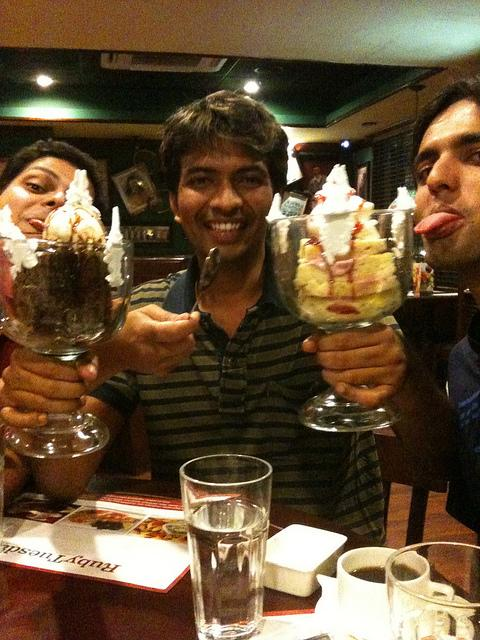In what year did this company exit bankruptcy? Please explain your reasoning. 2021. Ruby tuesday was able to exit bankruptcy this year. 